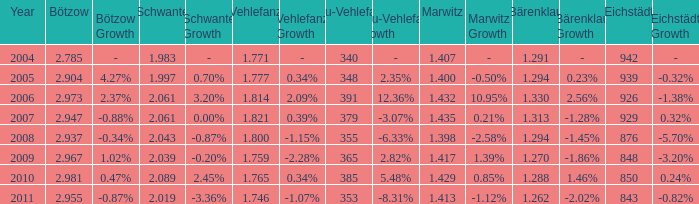What year has a Schwante smaller than 2.043, an Eichstädt smaller than 848, and a Bärenklau smaller than 1.262? 0.0. 